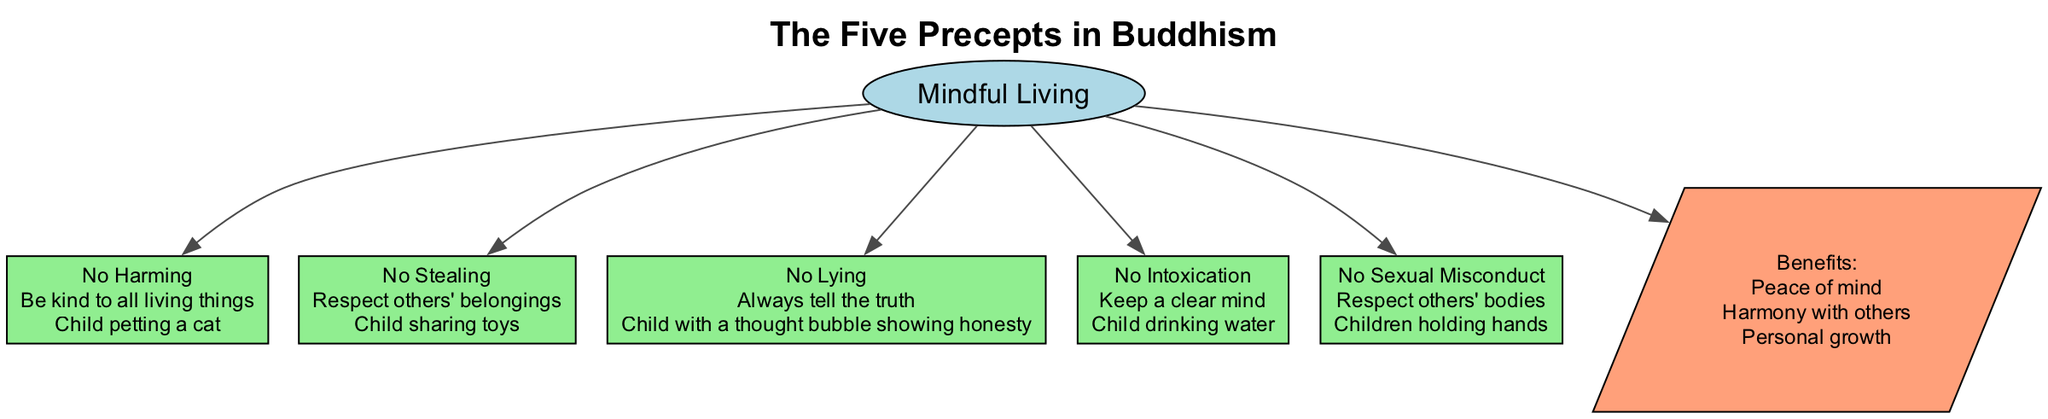What is the central concept of the diagram? The central concept is explicitly stated in the diagram as "Mindful Living," which is located in an ellipse shape in the center.
Answer: Mindful Living How many precepts are illustrated in the diagram? The diagram lists five precepts, each shown in a box connected to the central concept. The count can be verified by visually counting the boxes labeled with precept names.
Answer: 5 What does the first precept emphasize? The first precept, "No Harming," is specifically highlighted in the diagram with its explanation stating, "Be kind to all living things." This focuses on kindness and compassion.
Answer: Be kind to all living things Which precept encourages sharing? The precept labeled "No Stealing" includes the explanation "Respect others' belongings," which perfectly aligns with the concept of sharing as depicted in the illustration of children sharing toys.
Answer: No Stealing What type of illustration is used for "No Intoxication"? The illustration for "No Intoxication" shows a child drinking water. This visual representation helps reinforce the idea of keeping a clear mind through simple imagery.
Answer: Child drinking water List two benefits mentioned in the diagram. The diagram lists several benefits and mentions "Peace of mind" and "Harmony with others" as two of them, which are clearly stated in the benefits section.
Answer: Peace of mind, Harmony with others How do the precepts relate to personal growth? The precepts are outlined to show how they collectively contribute to personal growth, as seen by their connection to the central concept and their integration into mindful living practices. This reasoning indicates a relationship between understanding the precepts and achieving growth.
Answer: Personal growth What shape represents the benefits in the diagram? The benefits are represented in a parallelogram shape, which is distinct from other shapes used for the precepts and central concept, indicating its unique status in the diagram.
Answer: Parallelogram Which precept is associated with telling the truth? The precept "No Lying" is directly labeled in the diagram with an explanation that emphasizes honesty, clearly linking it to the concept of truthfulness.
Answer: No Lying 